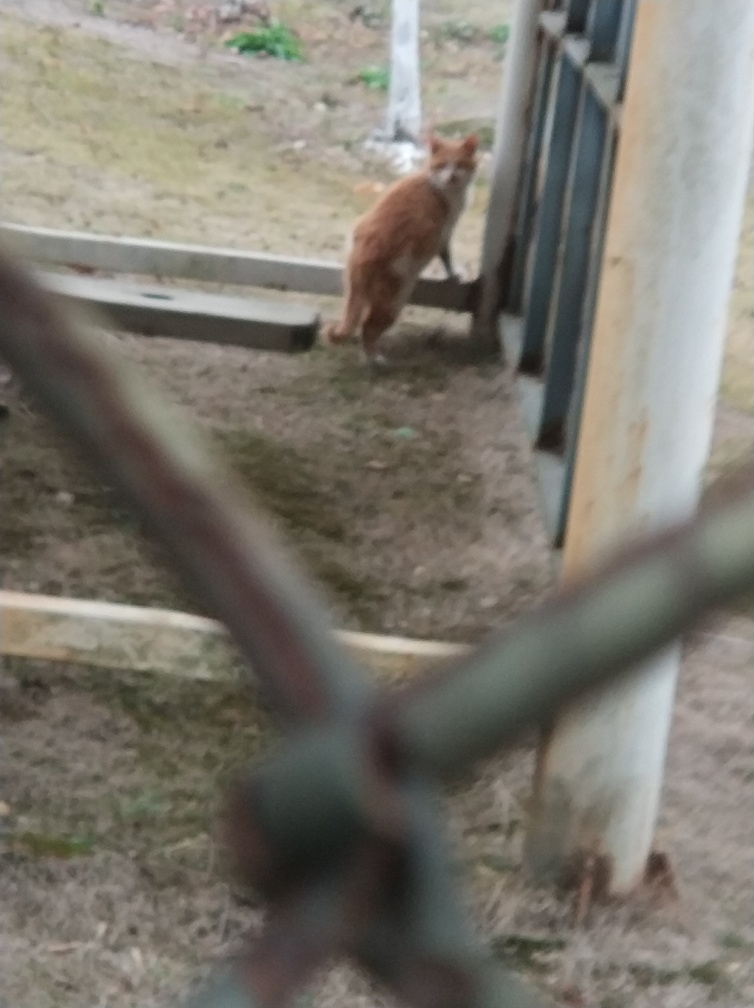Is there any noise present in the image? The image exhibits considerable visual noise, manifesting as a blur that impacts the clarity and details, especially noticeable around the edges and objects in the foreground. 